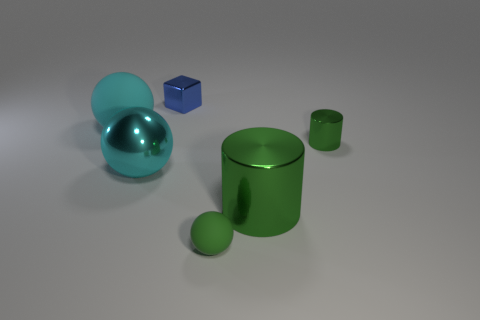Subtract all tiny green spheres. How many spheres are left? 2 Add 3 big green things. How many objects exist? 9 Subtract all blocks. How many objects are left? 5 Add 5 metal cubes. How many metal cubes are left? 6 Add 2 cyan matte spheres. How many cyan matte spheres exist? 3 Subtract 0 gray blocks. How many objects are left? 6 Subtract all small purple rubber spheres. Subtract all small green cylinders. How many objects are left? 5 